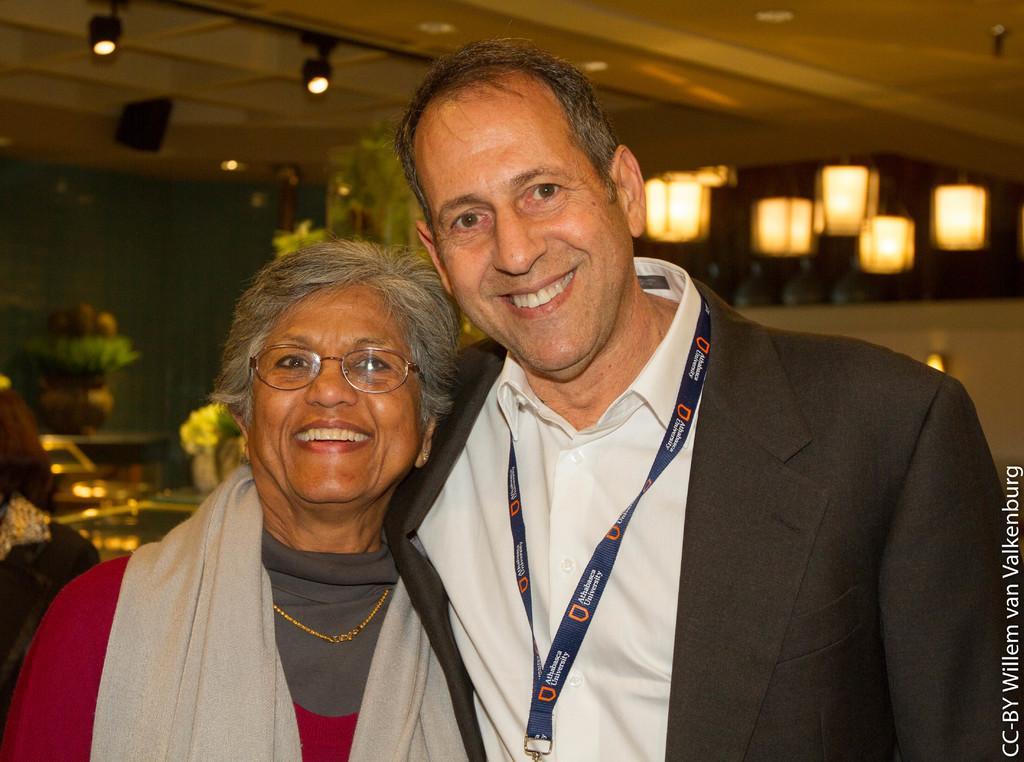Please provide a concise description of this image. In this image we can see there are two people standing and smiling, beside them there are few flower pots. At the top there is a ceiling with lights. 